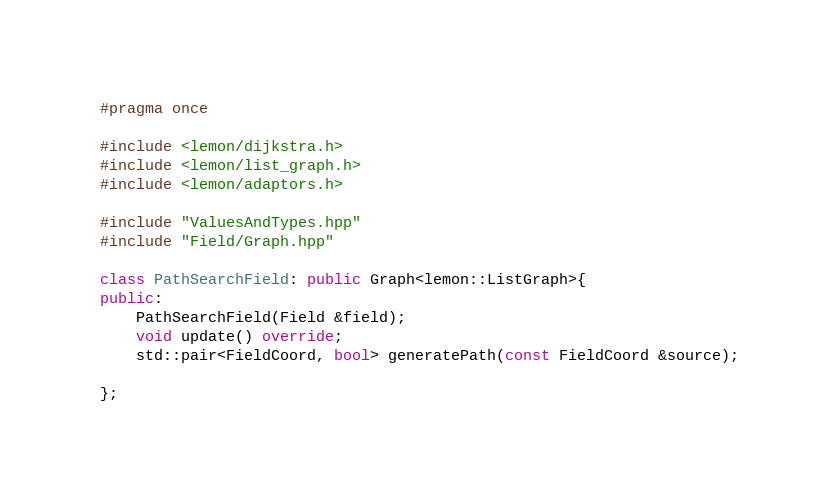<code> <loc_0><loc_0><loc_500><loc_500><_C++_>#pragma once

#include <lemon/dijkstra.h>
#include <lemon/list_graph.h>
#include <lemon/adaptors.h>

#include "ValuesAndTypes.hpp"
#include "Field/Graph.hpp"

class PathSearchField: public Graph<lemon::ListGraph>{
public:
    PathSearchField(Field &field);
    void update() override;
    std::pair<FieldCoord, bool> generatePath(const FieldCoord &source);

};</code> 